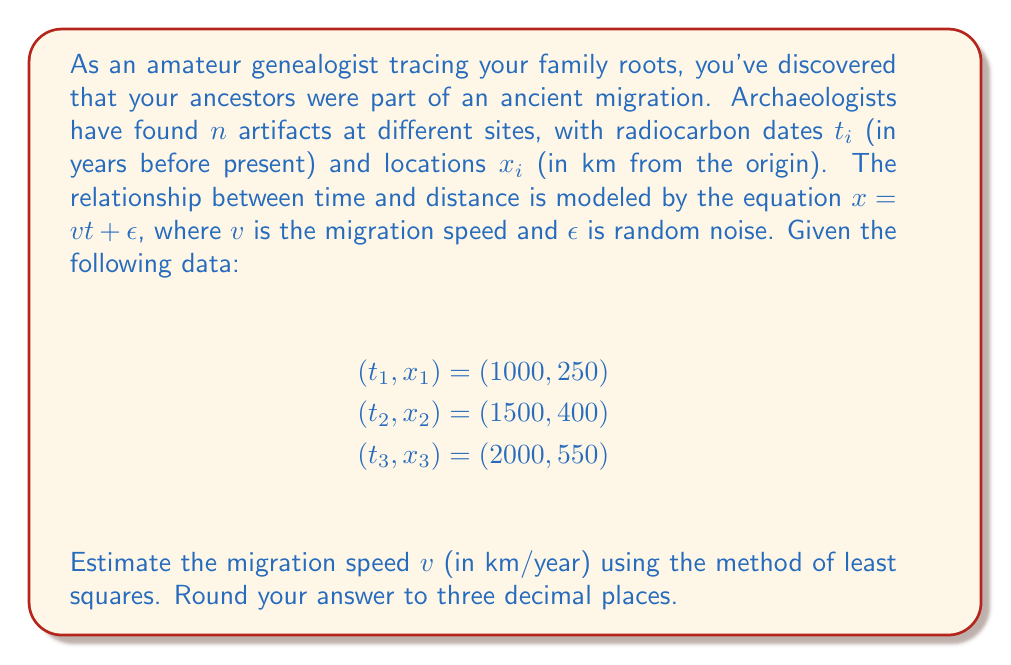Teach me how to tackle this problem. To solve this inverse problem and estimate the migration speed, we'll use the method of least squares:

1) The model equation is $x = vt + \epsilon$. We want to minimize the sum of squared errors:

   $$S = \sum_{i=1}^n (x_i - vt_i)^2$$

2) To find the minimum, we differentiate S with respect to v and set it to zero:

   $$\frac{dS}{dv} = -2\sum_{i=1}^n t_i(x_i - vt_i) = 0$$

3) Solving this equation:

   $$\sum_{i=1}^n t_ix_i = v\sum_{i=1}^n t_i^2$$

   $$v = \frac{\sum_{i=1}^n t_ix_i}{\sum_{i=1}^n t_i^2}$$

4) Now, let's calculate the sums:

   $$\sum_{i=1}^n t_ix_i = 1000 \cdot 250 + 1500 \cdot 400 + 2000 \cdot 550 = 1,850,000$$

   $$\sum_{i=1}^n t_i^2 = 1000^2 + 1500^2 + 2000^2 = 7,250,000$$

5) Substituting these values:

   $$v = \frac{1,850,000}{7,250,000} = 0.2551724138$$

6) Rounding to three decimal places:

   $$v \approx 0.255 \text{ km/year}$$
Answer: 0.255 km/year 